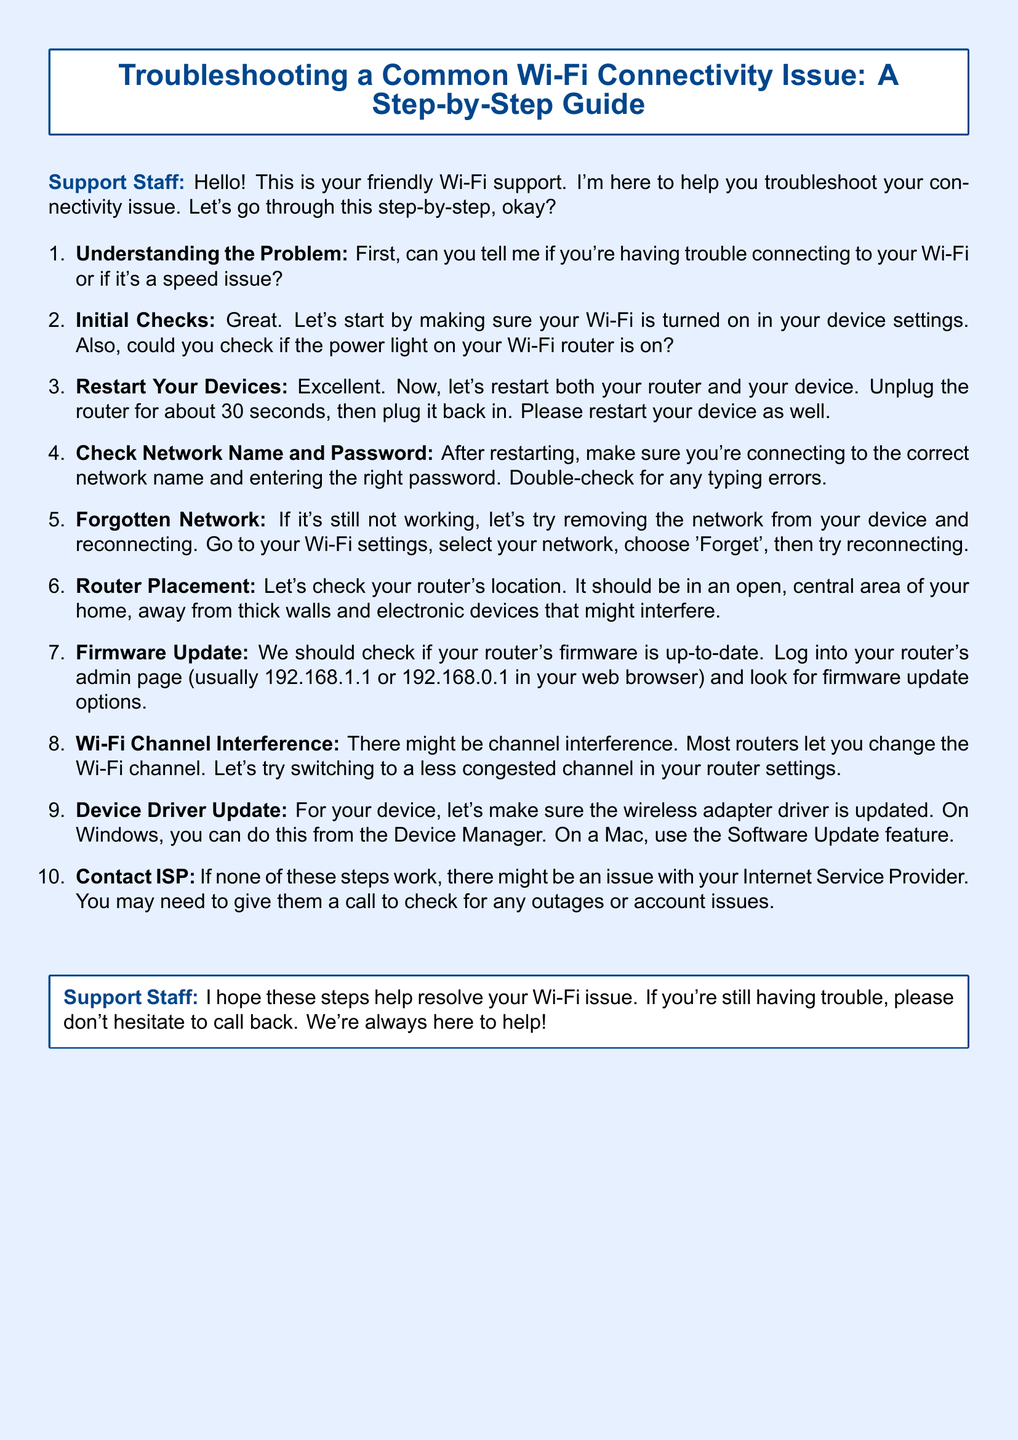What is the title of the document? The title of the document is stated at the beginning and clearly indicates the subject matter, which is troubleshooting Wi-Fi connectivity issues.
Answer: Troubleshooting a Common Wi-Fi Connectivity Issue: A Step-by-Step Guide Who is the speaker in the document? The speaker is identified at the start as the support staff who is helping with Wi-Fi issues.
Answer: Support Staff What is the first step in troubleshooting? The first step is clearly mentioned, asking the user to identify the type of connectivity issue they're experiencing.
Answer: Understanding the Problem How long should the router be unplugged during a restart? The document specifies a precise duration for how long the router should be unplugged to reset it.
Answer: 30 seconds What network-related settings should be checked? The document instructs users to verify both the network name and password to ensure correct connection.
Answer: Network name and password What should be checked regarding the router's placement? There is advice given about the ideal location of the router to avoid connectivity issues.
Answer: Open, central area What is one of the reasons to contact the ISP? The document hints at a specific action if all troubleshooting steps fail, pointing to a potential external issue.
Answer: Outages or account issues What device-specific software should be updated? The document suggests updating a specific driver on the device to ensure connectivity.
Answer: Wireless adapter driver What page should be accessed for router settings? The document provides common IP addresses used to log into the router’s admin page.
Answer: 192.168.1.1 or 192.168.0.1 